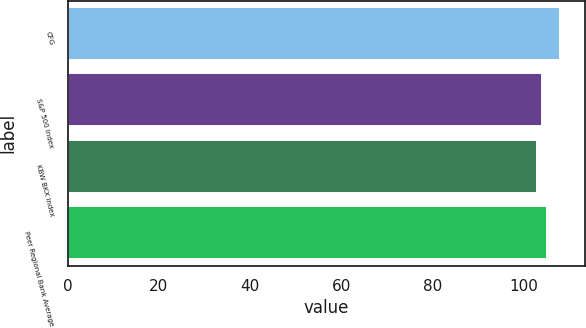Convert chart to OTSL. <chart><loc_0><loc_0><loc_500><loc_500><bar_chart><fcel>CFG<fcel>S&P 500 Index<fcel>KBW BKX Index<fcel>Peer Regional Bank Average<nl><fcel>108<fcel>104<fcel>103<fcel>105<nl></chart> 